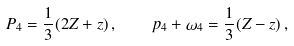<formula> <loc_0><loc_0><loc_500><loc_500>P _ { 4 } = \frac { 1 } { 3 } ( 2 Z + z ) \, , \quad p _ { 4 } + \omega _ { 4 } = \frac { 1 } { 3 } ( Z - z ) \, ,</formula> 